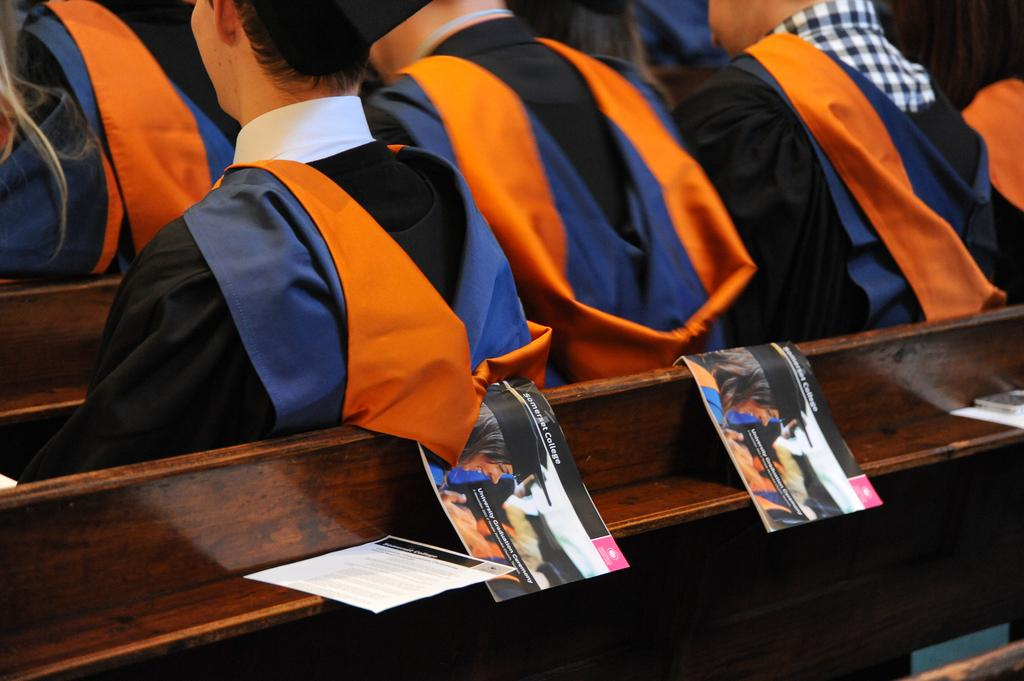What objects are on the wooden surface in the foreground of the image? There are papers and booklets on the wooden surface in the foreground of the image. What can be seen in the immediate area of the wooden surface? There are persons sitting in the foreground of the image. What direction is the mist coming from in the image? There is no mention of mist in the image, so it cannot be determined from which direction it might be coming. 